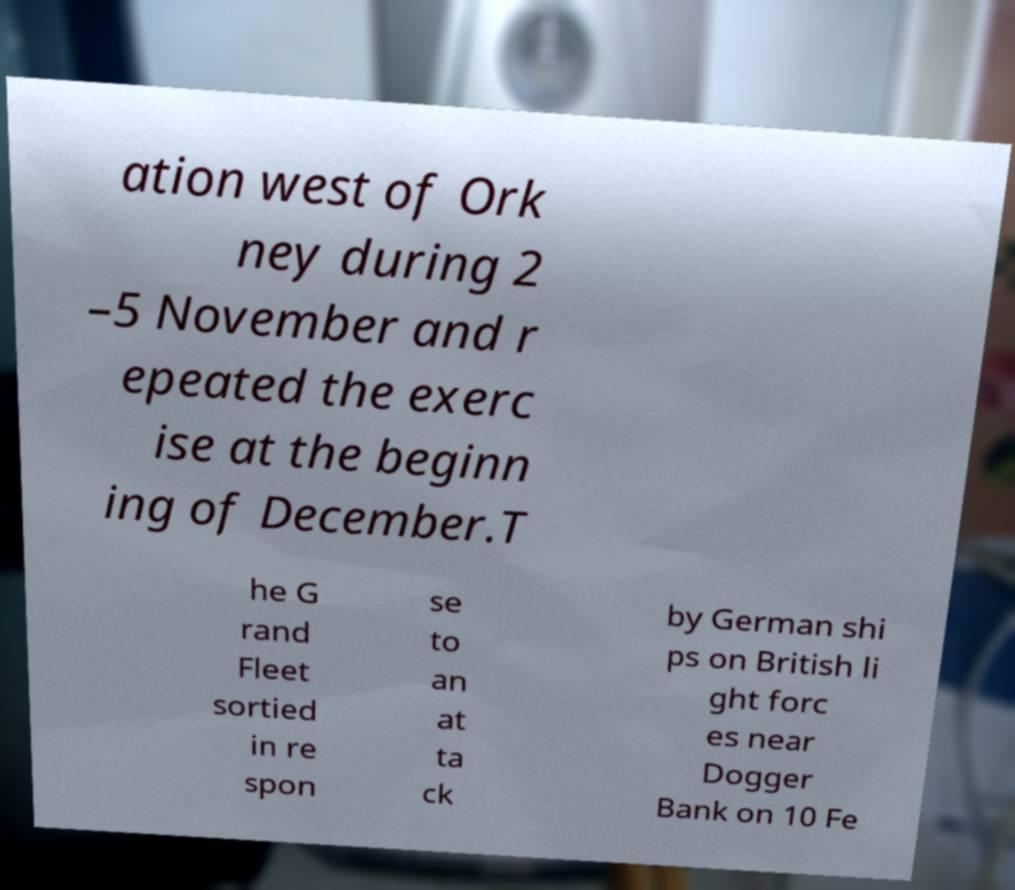Can you read and provide the text displayed in the image?This photo seems to have some interesting text. Can you extract and type it out for me? ation west of Ork ney during 2 –5 November and r epeated the exerc ise at the beginn ing of December.T he G rand Fleet sortied in re spon se to an at ta ck by German shi ps on British li ght forc es near Dogger Bank on 10 Fe 